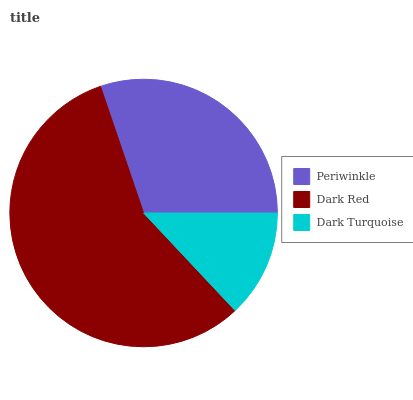Is Dark Turquoise the minimum?
Answer yes or no. Yes. Is Dark Red the maximum?
Answer yes or no. Yes. Is Dark Red the minimum?
Answer yes or no. No. Is Dark Turquoise the maximum?
Answer yes or no. No. Is Dark Red greater than Dark Turquoise?
Answer yes or no. Yes. Is Dark Turquoise less than Dark Red?
Answer yes or no. Yes. Is Dark Turquoise greater than Dark Red?
Answer yes or no. No. Is Dark Red less than Dark Turquoise?
Answer yes or no. No. Is Periwinkle the high median?
Answer yes or no. Yes. Is Periwinkle the low median?
Answer yes or no. Yes. Is Dark Turquoise the high median?
Answer yes or no. No. Is Dark Turquoise the low median?
Answer yes or no. No. 